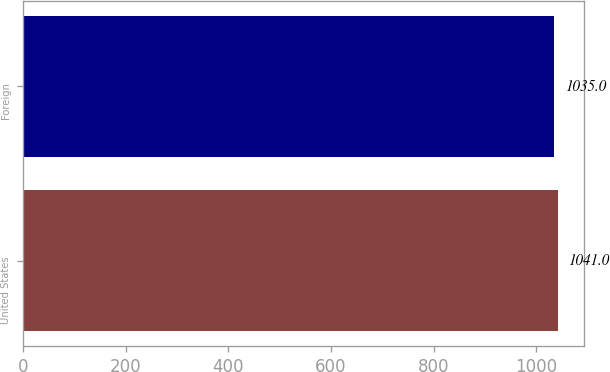<chart> <loc_0><loc_0><loc_500><loc_500><bar_chart><fcel>United States<fcel>Foreign<nl><fcel>1041<fcel>1035<nl></chart> 